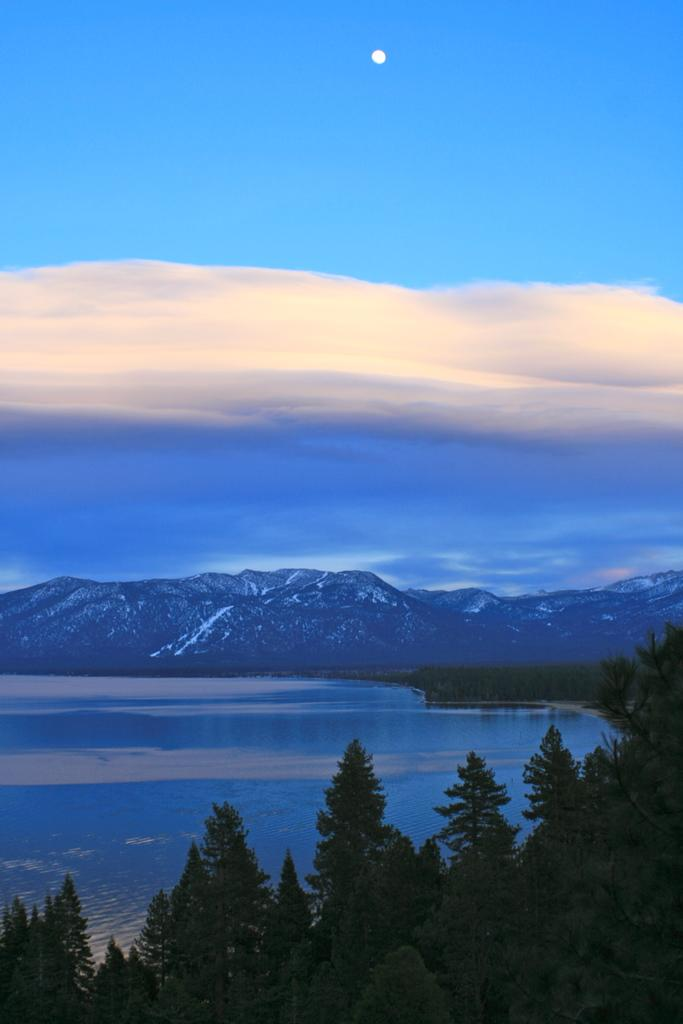What is the primary element in the image? There is water in the image. What type of vegetation can be seen on the right side of the image? There are trees on the right side of the image. What geographical features are visible in the background of the image? There are hills visible in the background of the image. What can be seen in the sky in the image? Clouds are present in the sky. How many friends are visible in the image? There are no friends present in the image. What type of shoe can be seen floating in the water? There is no shoe present in the image. 